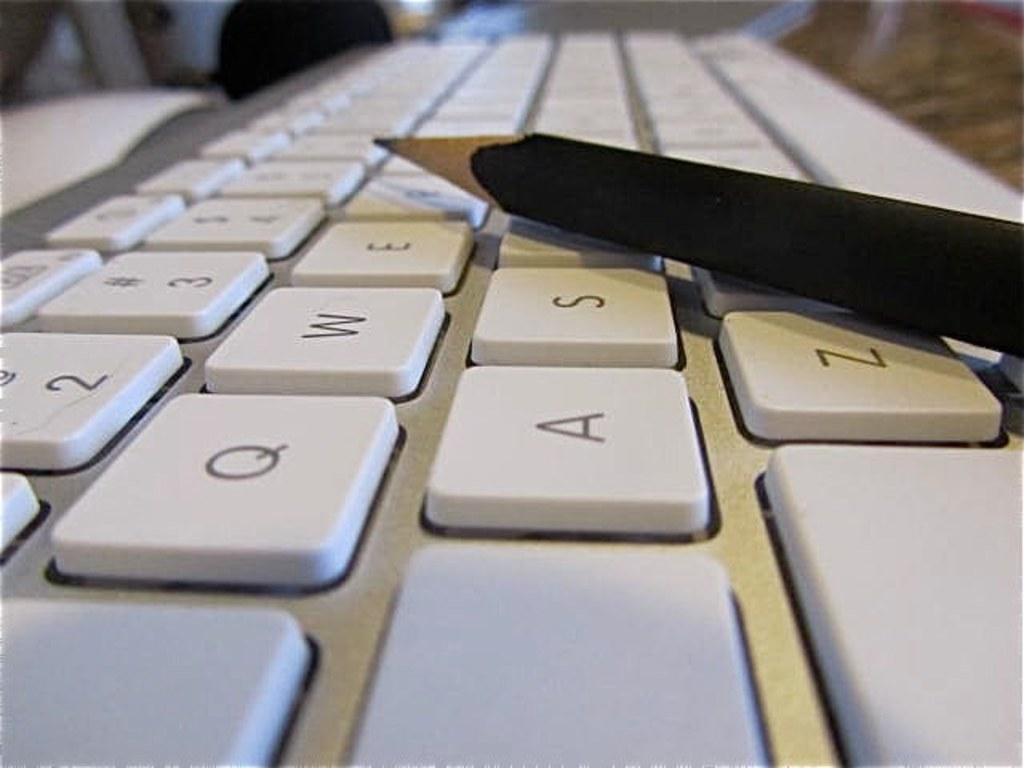<image>
Present a compact description of the photo's key features. A pencil is laying on a keyboard next to the S, Z, and E keys. 